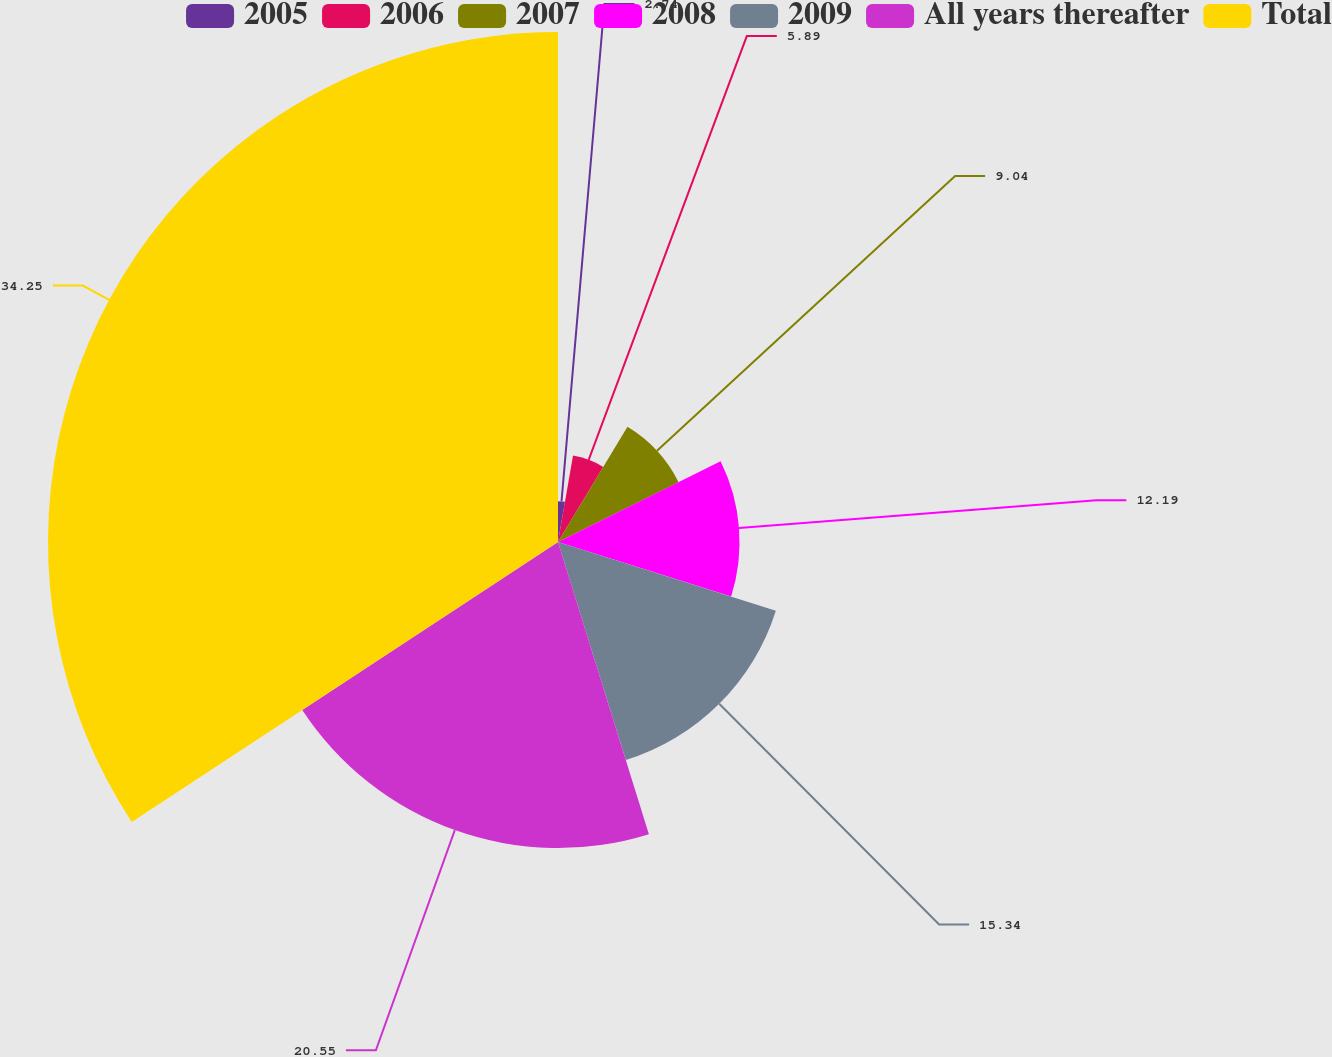Convert chart to OTSL. <chart><loc_0><loc_0><loc_500><loc_500><pie_chart><fcel>2005<fcel>2006<fcel>2007<fcel>2008<fcel>2009<fcel>All years thereafter<fcel>Total<nl><fcel>2.74%<fcel>5.89%<fcel>9.04%<fcel>12.19%<fcel>15.34%<fcel>20.55%<fcel>34.25%<nl></chart> 